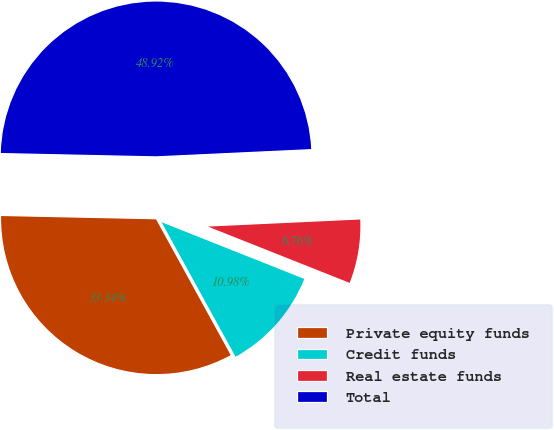Convert chart to OTSL. <chart><loc_0><loc_0><loc_500><loc_500><pie_chart><fcel>Private equity funds<fcel>Credit funds<fcel>Real estate funds<fcel>Total<nl><fcel>33.34%<fcel>10.98%<fcel>6.76%<fcel>48.92%<nl></chart> 